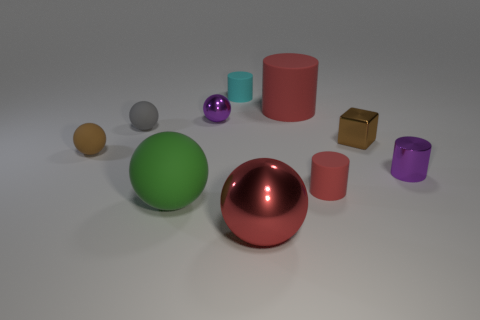Subtract 2 spheres. How many spheres are left? 3 Subtract all purple spheres. How many spheres are left? 4 Subtract all brown rubber balls. How many balls are left? 4 Subtract all cyan spheres. Subtract all purple blocks. How many spheres are left? 5 Subtract all cylinders. How many objects are left? 6 Add 8 green matte objects. How many green matte objects are left? 9 Add 6 big purple matte balls. How many big purple matte balls exist? 6 Subtract 0 red blocks. How many objects are left? 10 Subtract all large metal spheres. Subtract all large red shiny things. How many objects are left? 8 